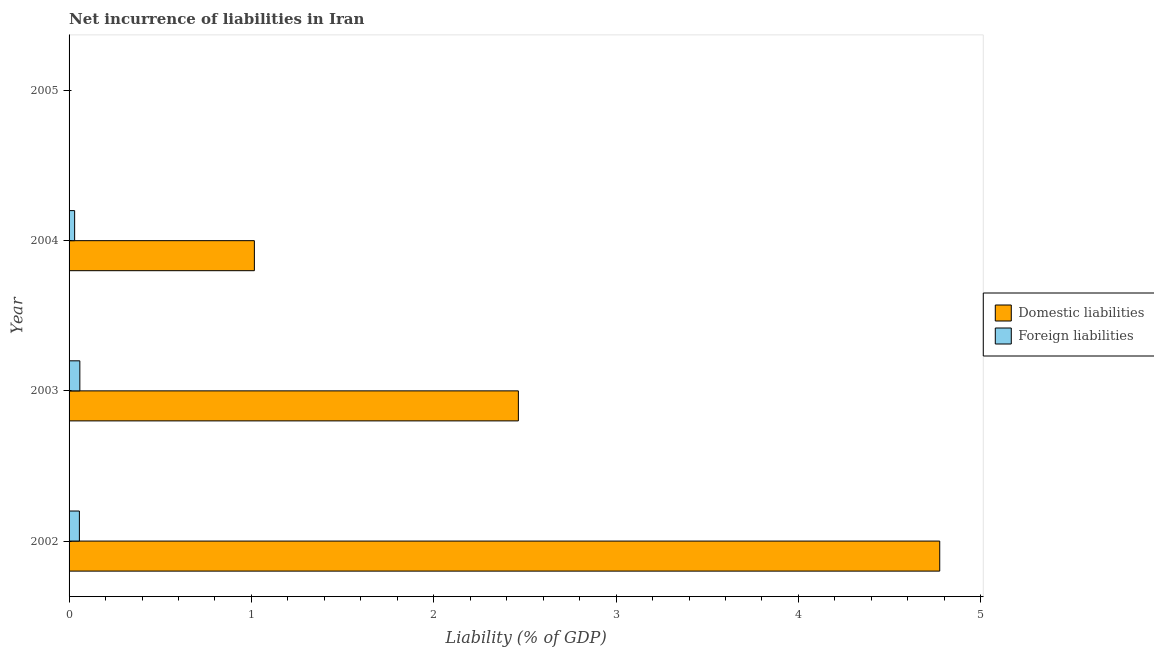How many different coloured bars are there?
Your response must be concise. 2. Are the number of bars on each tick of the Y-axis equal?
Provide a succinct answer. No. How many bars are there on the 4th tick from the top?
Your answer should be compact. 2. What is the label of the 4th group of bars from the top?
Offer a very short reply. 2002. In how many cases, is the number of bars for a given year not equal to the number of legend labels?
Provide a short and direct response. 1. What is the incurrence of domestic liabilities in 2003?
Provide a succinct answer. 2.46. Across all years, what is the maximum incurrence of foreign liabilities?
Your response must be concise. 0.06. Across all years, what is the minimum incurrence of domestic liabilities?
Make the answer very short. 0. What is the total incurrence of domestic liabilities in the graph?
Keep it short and to the point. 8.26. What is the difference between the incurrence of domestic liabilities in 2003 and that in 2004?
Your answer should be compact. 1.45. What is the difference between the incurrence of domestic liabilities in 2004 and the incurrence of foreign liabilities in 2005?
Give a very brief answer. 1.02. What is the average incurrence of foreign liabilities per year?
Make the answer very short. 0.04. In the year 2004, what is the difference between the incurrence of foreign liabilities and incurrence of domestic liabilities?
Offer a very short reply. -0.99. In how many years, is the incurrence of foreign liabilities greater than 0.4 %?
Offer a terse response. 0. What is the ratio of the incurrence of domestic liabilities in 2003 to that in 2004?
Offer a very short reply. 2.42. Is the incurrence of domestic liabilities in 2003 less than that in 2004?
Your answer should be very brief. No. Is the difference between the incurrence of domestic liabilities in 2002 and 2004 greater than the difference between the incurrence of foreign liabilities in 2002 and 2004?
Your answer should be compact. Yes. What is the difference between the highest and the second highest incurrence of foreign liabilities?
Your response must be concise. 0. What is the difference between the highest and the lowest incurrence of domestic liabilities?
Your answer should be compact. 4.78. In how many years, is the incurrence of foreign liabilities greater than the average incurrence of foreign liabilities taken over all years?
Offer a very short reply. 2. How many bars are there?
Ensure brevity in your answer.  6. Are all the bars in the graph horizontal?
Give a very brief answer. Yes. How many years are there in the graph?
Provide a short and direct response. 4. Does the graph contain any zero values?
Give a very brief answer. Yes. Where does the legend appear in the graph?
Your response must be concise. Center right. How many legend labels are there?
Keep it short and to the point. 2. How are the legend labels stacked?
Your response must be concise. Vertical. What is the title of the graph?
Make the answer very short. Net incurrence of liabilities in Iran. What is the label or title of the X-axis?
Provide a short and direct response. Liability (% of GDP). What is the label or title of the Y-axis?
Make the answer very short. Year. What is the Liability (% of GDP) in Domestic liabilities in 2002?
Your answer should be very brief. 4.78. What is the Liability (% of GDP) in Foreign liabilities in 2002?
Your answer should be very brief. 0.06. What is the Liability (% of GDP) of Domestic liabilities in 2003?
Provide a short and direct response. 2.46. What is the Liability (% of GDP) in Foreign liabilities in 2003?
Give a very brief answer. 0.06. What is the Liability (% of GDP) in Domestic liabilities in 2004?
Give a very brief answer. 1.02. What is the Liability (% of GDP) of Foreign liabilities in 2004?
Your answer should be very brief. 0.03. What is the Liability (% of GDP) of Foreign liabilities in 2005?
Ensure brevity in your answer.  0. Across all years, what is the maximum Liability (% of GDP) of Domestic liabilities?
Make the answer very short. 4.78. Across all years, what is the maximum Liability (% of GDP) of Foreign liabilities?
Your response must be concise. 0.06. What is the total Liability (% of GDP) of Domestic liabilities in the graph?
Your answer should be very brief. 8.26. What is the total Liability (% of GDP) in Foreign liabilities in the graph?
Make the answer very short. 0.15. What is the difference between the Liability (% of GDP) of Domestic liabilities in 2002 and that in 2003?
Offer a terse response. 2.31. What is the difference between the Liability (% of GDP) of Foreign liabilities in 2002 and that in 2003?
Provide a short and direct response. -0. What is the difference between the Liability (% of GDP) of Domestic liabilities in 2002 and that in 2004?
Provide a succinct answer. 3.76. What is the difference between the Liability (% of GDP) of Foreign liabilities in 2002 and that in 2004?
Give a very brief answer. 0.03. What is the difference between the Liability (% of GDP) of Domestic liabilities in 2003 and that in 2004?
Provide a succinct answer. 1.45. What is the difference between the Liability (% of GDP) in Foreign liabilities in 2003 and that in 2004?
Provide a succinct answer. 0.03. What is the difference between the Liability (% of GDP) of Domestic liabilities in 2002 and the Liability (% of GDP) of Foreign liabilities in 2003?
Your response must be concise. 4.72. What is the difference between the Liability (% of GDP) of Domestic liabilities in 2002 and the Liability (% of GDP) of Foreign liabilities in 2004?
Make the answer very short. 4.74. What is the difference between the Liability (% of GDP) of Domestic liabilities in 2003 and the Liability (% of GDP) of Foreign liabilities in 2004?
Your response must be concise. 2.43. What is the average Liability (% of GDP) of Domestic liabilities per year?
Give a very brief answer. 2.06. What is the average Liability (% of GDP) of Foreign liabilities per year?
Ensure brevity in your answer.  0.04. In the year 2002, what is the difference between the Liability (% of GDP) of Domestic liabilities and Liability (% of GDP) of Foreign liabilities?
Provide a short and direct response. 4.72. In the year 2003, what is the difference between the Liability (% of GDP) of Domestic liabilities and Liability (% of GDP) of Foreign liabilities?
Your answer should be compact. 2.41. In the year 2004, what is the difference between the Liability (% of GDP) in Domestic liabilities and Liability (% of GDP) in Foreign liabilities?
Provide a short and direct response. 0.99. What is the ratio of the Liability (% of GDP) in Domestic liabilities in 2002 to that in 2003?
Your answer should be compact. 1.94. What is the ratio of the Liability (% of GDP) in Foreign liabilities in 2002 to that in 2003?
Your response must be concise. 0.96. What is the ratio of the Liability (% of GDP) in Domestic liabilities in 2002 to that in 2004?
Your response must be concise. 4.7. What is the ratio of the Liability (% of GDP) of Foreign liabilities in 2002 to that in 2004?
Your answer should be very brief. 1.85. What is the ratio of the Liability (% of GDP) of Domestic liabilities in 2003 to that in 2004?
Provide a short and direct response. 2.42. What is the ratio of the Liability (% of GDP) of Foreign liabilities in 2003 to that in 2004?
Provide a succinct answer. 1.93. What is the difference between the highest and the second highest Liability (% of GDP) in Domestic liabilities?
Provide a short and direct response. 2.31. What is the difference between the highest and the second highest Liability (% of GDP) of Foreign liabilities?
Offer a very short reply. 0. What is the difference between the highest and the lowest Liability (% of GDP) in Domestic liabilities?
Provide a succinct answer. 4.78. What is the difference between the highest and the lowest Liability (% of GDP) in Foreign liabilities?
Ensure brevity in your answer.  0.06. 